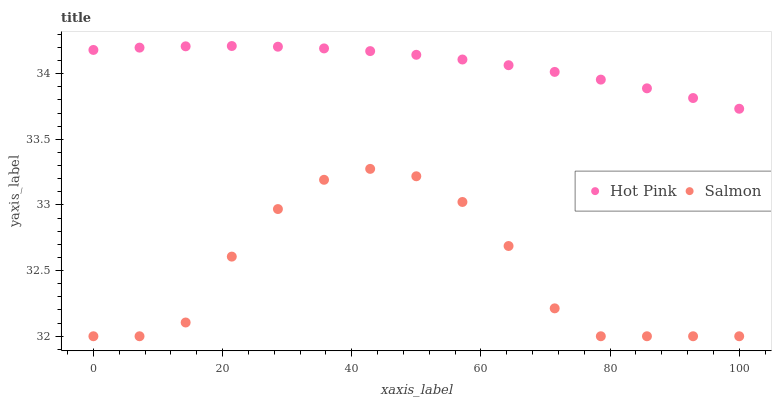Does Salmon have the minimum area under the curve?
Answer yes or no. Yes. Does Hot Pink have the maximum area under the curve?
Answer yes or no. Yes. Does Salmon have the maximum area under the curve?
Answer yes or no. No. Is Hot Pink the smoothest?
Answer yes or no. Yes. Is Salmon the roughest?
Answer yes or no. Yes. Is Salmon the smoothest?
Answer yes or no. No. Does Salmon have the lowest value?
Answer yes or no. Yes. Does Hot Pink have the highest value?
Answer yes or no. Yes. Does Salmon have the highest value?
Answer yes or no. No. Is Salmon less than Hot Pink?
Answer yes or no. Yes. Is Hot Pink greater than Salmon?
Answer yes or no. Yes. Does Salmon intersect Hot Pink?
Answer yes or no. No. 